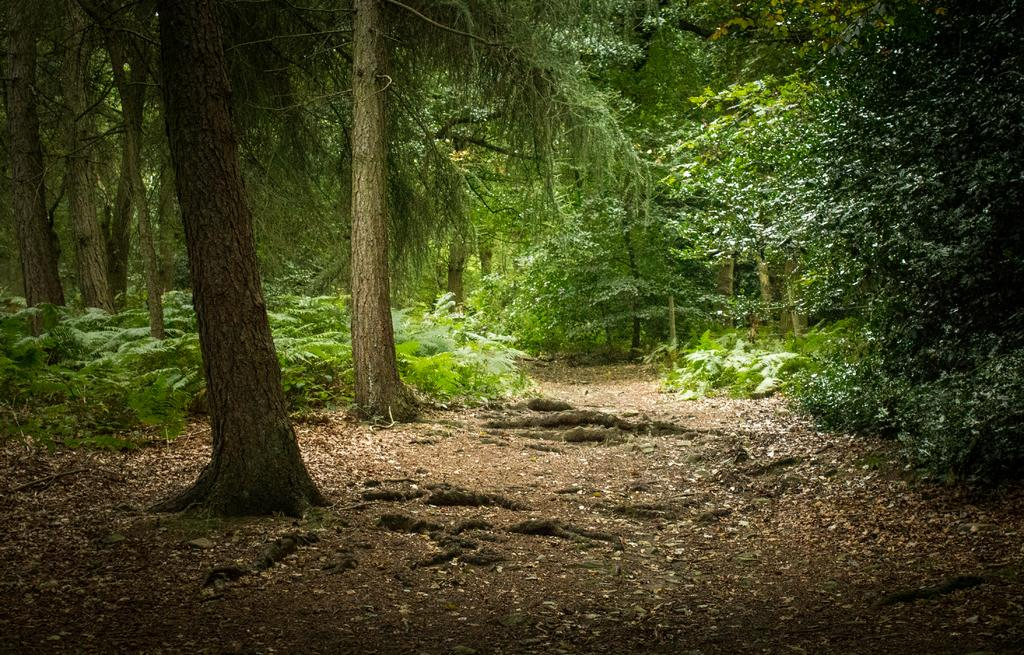What type of vegetation is present in the image? There are green plants and trees in the image. Can you describe the color of the plants? The green plants in the image have a green color. What else can be seen in the image besides the plants and trees? The provided facts do not mention any other objects or elements in the image. What type of car is parked next to the trees in the image? There is no car present in the image; it only features green plants and trees. What color is the dress worn by the tree in the image? Trees do not wear dresses, and there is no dress present in the image. 